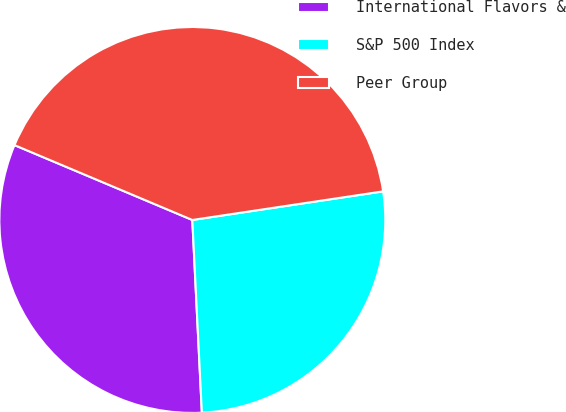Convert chart to OTSL. <chart><loc_0><loc_0><loc_500><loc_500><pie_chart><fcel>International Flavors &<fcel>S&P 500 Index<fcel>Peer Group<nl><fcel>32.13%<fcel>26.58%<fcel>41.29%<nl></chart> 